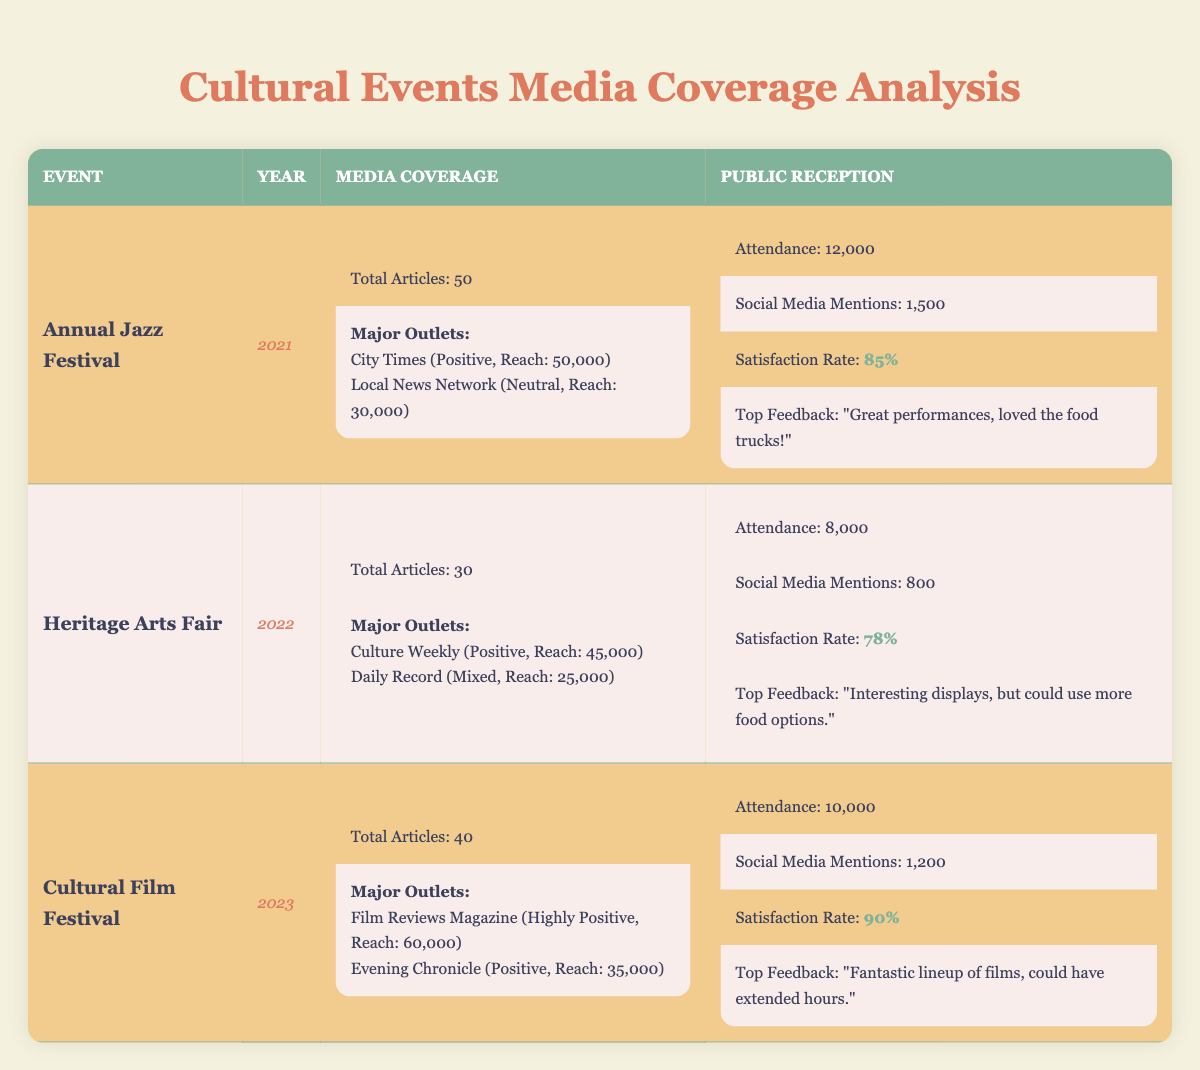What was the total attendance for the Annual Jazz Festival in 2021? The table states the attendance for the Annual Jazz Festival in 2021 is listed directly under that event, which is 12,000.
Answer: 12,000 Which media outlet had the highest reach for the Cultural Film Festival in 2023? For the Cultural Film Festival, the media outlet with the highest reach is Film Reviews Magazine, which had a reach of 60,000.
Answer: Film Reviews Magazine What is the average satisfaction rate across all three events? The satisfaction rates are 85% for the Annual Jazz Festival, 78% for the Heritage Arts Fair, and 90% for the Cultural Film Festival. To find the average, add the percentages: 85 + 78 + 90 = 253, then divide by 3: 253 / 3 = 84.33.
Answer: 84.33 Did the Heritage Arts Fair receive more media coverage than the Annual Jazz Festival in terms of total articles? The Annual Jazz Festival had 50 total articles, while the Heritage Arts Fair had 30 total articles, which shows that the Annual Jazz Festival received more media coverage.
Answer: No Which event had the most social media mentions and what was the number? The Annual Jazz Festival had 1,500 social media mentions, the Heritage Arts Fair had 800, and the Cultural Film Festival had 1,200. The highest number of social media mentions is from the Annual Jazz Festival with 1,500.
Answer: 1,500 What was the sentiment of the major outlets covering the Heritage Arts Fair? The major outlets covering the Heritage Arts Fair are Culture Weekly, which had a positive sentiment, and Daily Record, which had a mixed sentiment.
Answer: Positive and Mixed How many total articles were published across all events? The total articles for each event are 50 for the Annual Jazz Festival, 30 for the Heritage Arts Fair, and 40 for the Cultural Film Festival. When summed up: 50 + 30 + 40 = 120 total articles.
Answer: 120 Was the attendance for the Cultural Film Festival in 2023 greater than the Heritage Arts Fair in 2022? The attendance for the Cultural Film Festival is 10,000 and for the Heritage Arts Fair it is 8,000. Thus, the attendance for the Cultural Film Festival is greater.
Answer: Yes Which event had the highest satisfaction rate and what was it? The satisfaction rates are 85% for the Annual Jazz Festival, 78% for the Heritage Arts Fair, and 90% for the Cultural Film Festival. The Cultural Film Festival had the highest satisfaction rate at 90%.
Answer: 90% 